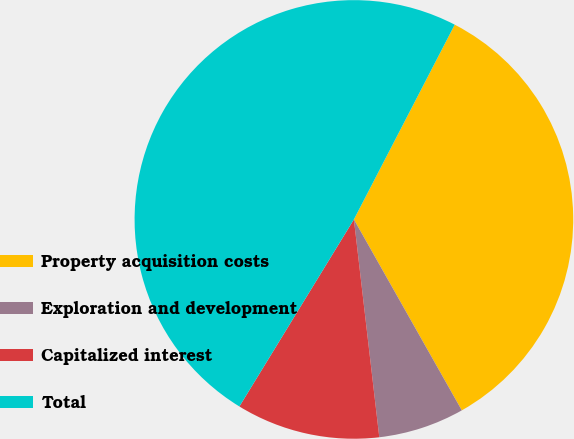Convert chart. <chart><loc_0><loc_0><loc_500><loc_500><pie_chart><fcel>Property acquisition costs<fcel>Exploration and development<fcel>Capitalized interest<fcel>Total<nl><fcel>34.21%<fcel>6.34%<fcel>10.59%<fcel>48.86%<nl></chart> 